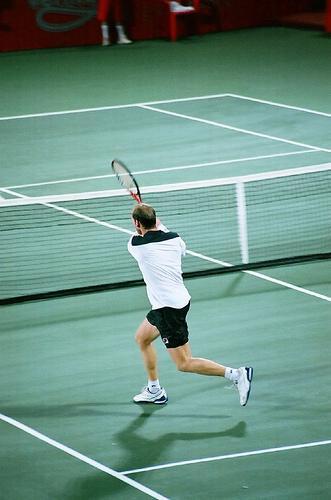How many people are shown?
Give a very brief answer. 2. How many players are shown?
Give a very brief answer. 1. 